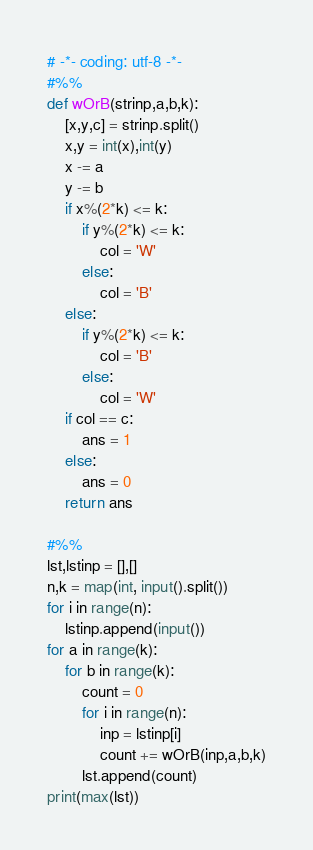Convert code to text. <code><loc_0><loc_0><loc_500><loc_500><_Python_># -*- coding: utf-8 -*-
#%%
def wOrB(strinp,a,b,k):
    [x,y,c] = strinp.split()
    x,y = int(x),int(y)
    x -= a
    y -= b
    if x%(2*k) <= k:
        if y%(2*k) <= k:
            col = 'W'
        else:
            col = 'B'
    else:
        if y%(2*k) <= k:
            col = 'B'
        else:
            col = 'W'
    if col == c:
        ans = 1
    else:
        ans = 0
    return ans

#%%
lst,lstinp = [],[]
n,k = map(int, input().split())
for i in range(n):
    lstinp.append(input())
for a in range(k):
    for b in range(k):
        count = 0
        for i in range(n):
            inp = lstinp[i]
            count += wOrB(inp,a,b,k)
        lst.append(count)
print(max(lst))
</code> 